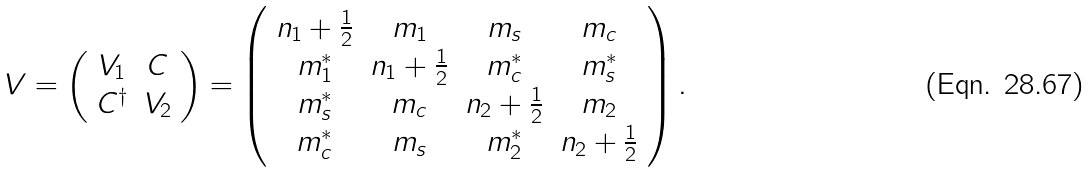Convert formula to latex. <formula><loc_0><loc_0><loc_500><loc_500>V = \left ( \begin{array} { c c } V _ { 1 } & C \\ C ^ { \dagger } & V _ { 2 } \end{array} \right ) = \left ( \begin{array} { c c c c } n _ { 1 } + \frac { 1 } { 2 } & m _ { 1 } & m _ { s } & m _ { c } \\ m _ { 1 } ^ { * } & n _ { 1 } + \frac { 1 } { 2 } & m _ { c } ^ { * } & m _ { s } ^ { * } \\ m _ { s } ^ { * } & m _ { c } & n _ { 2 } + \frac { 1 } { 2 } & m _ { 2 } \\ m _ { c } ^ { * } & m _ { s } & m _ { 2 } ^ { * } & n _ { 2 } + \frac { 1 } { 2 } \\ \end{array} \right ) .</formula> 